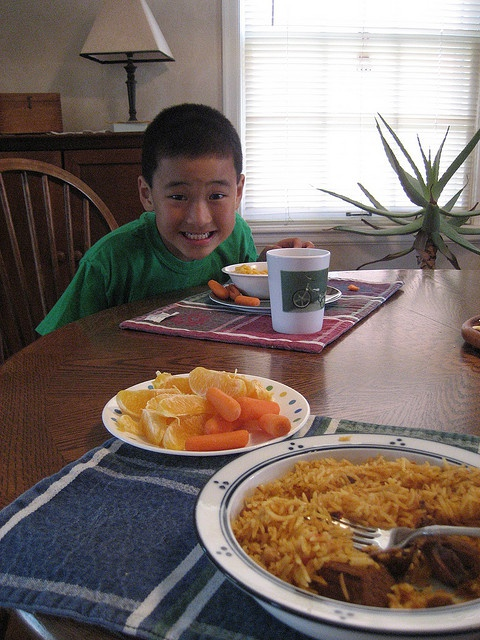Describe the objects in this image and their specific colors. I can see bowl in purple, olive, black, maroon, and darkgray tones, dining table in purple, maroon, darkgray, black, and gray tones, people in purple, black, maroon, brown, and gray tones, chair in purple, black, maroon, and brown tones, and potted plant in purple, whitesmoke, gray, black, and darkgray tones in this image. 